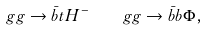Convert formula to latex. <formula><loc_0><loc_0><loc_500><loc_500>g g \to \bar { b } t H ^ { - } \quad g g \to \bar { b } b \Phi ,</formula> 